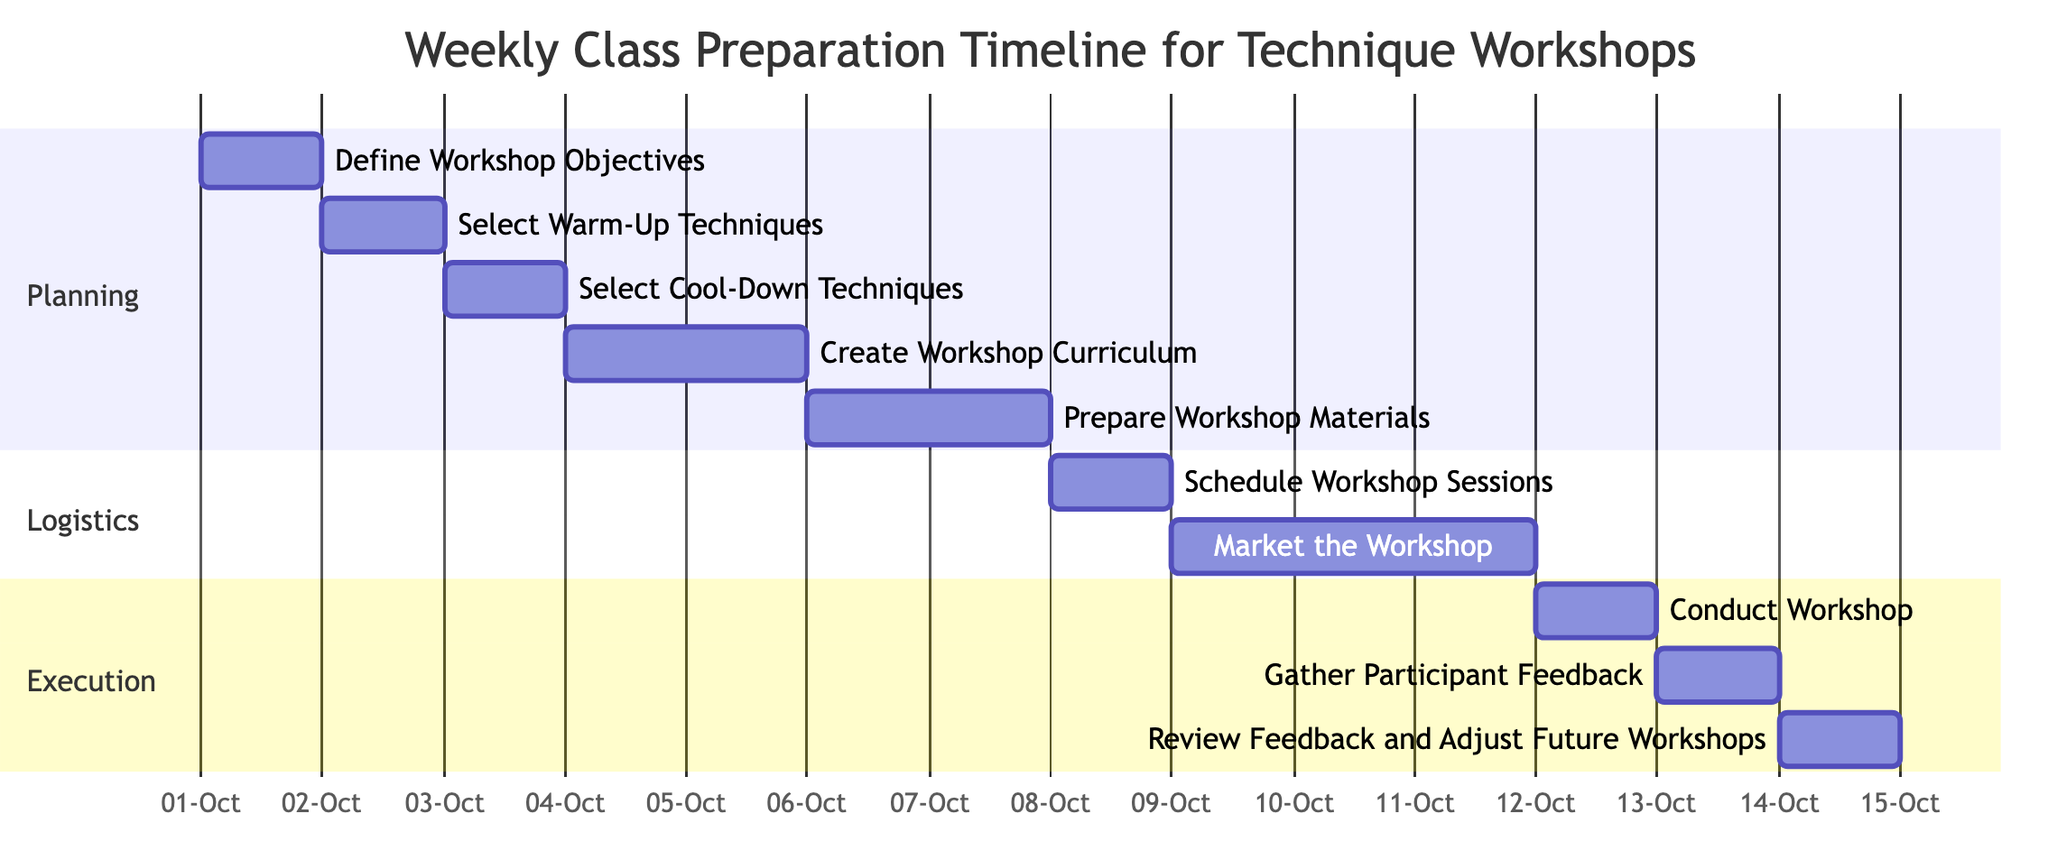What is the duration of the task 'Market the Workshop'? The duration of the task 'Market the Workshop' is specified in the diagram as 3 days.
Answer: 3 days What day does 'Conduct Workshop' occur? The 'Conduct Workshop' task is indicated to start and end on the same day, which is October 12, 2023.
Answer: 12-Oct-2023 How many tasks are listed in the 'Logistics' section? By examining the 'Logistics' section, there are two tasks: 'Schedule Workshop Sessions' and 'Market the Workshop'.
Answer: 2 Which task immediately follows 'Prepare Workshop Materials'? Looking at the sequence of tasks, the task that follows 'Prepare Workshop Materials' is 'Schedule Workshop Sessions'.
Answer: Schedule Workshop Sessions What is the total number of tasks in the Gantt Chart? By counting all task entries in the diagram, a total of ten tasks can be identified.
Answer: 10 Which task has the earliest start date? The earliest start date in the chart corresponds to 'Define Workshop Objectives', which starts on October 1, 2023.
Answer: Define Workshop Objectives How many days are allocated for 'Create Workshop Curriculum'? The duration allocated for 'Create Workshop Curriculum' is 2 days, as denoted in the diagram.
Answer: 2 days What are the tasks listed in the 'Execution' section? The 'Execution' section contains the following tasks: 'Conduct Workshop', 'Gather Participant Feedback', and 'Review Feedback and Adjust Future Workshops'.
Answer: Conduct Workshop, Gather Participant Feedback, Review Feedback and Adjust Future Workshops Which task receives feedback after its completion? The task that gathers feedback after its execution is 'Gather Participant Feedback', which takes place the day after 'Conduct Workshop'.
Answer: Gather Participant Feedback 